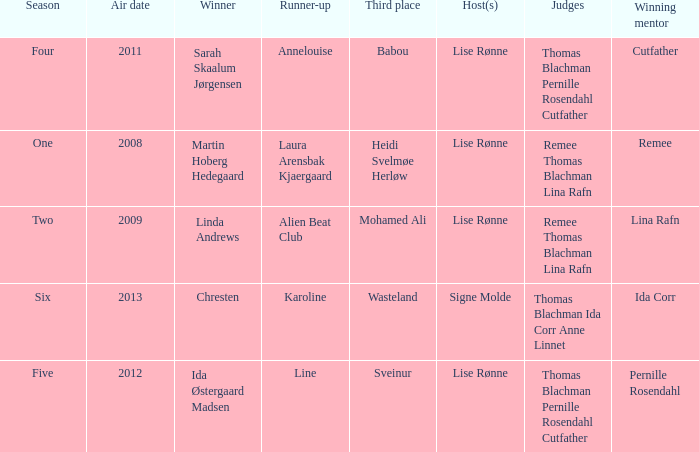Who was the winning mentor in season two? Lina Rafn. 